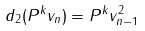Convert formula to latex. <formula><loc_0><loc_0><loc_500><loc_500>d _ { 2 } ( P ^ { k } v _ { n } ) = P ^ { k } v _ { n - 1 } ^ { 2 }</formula> 